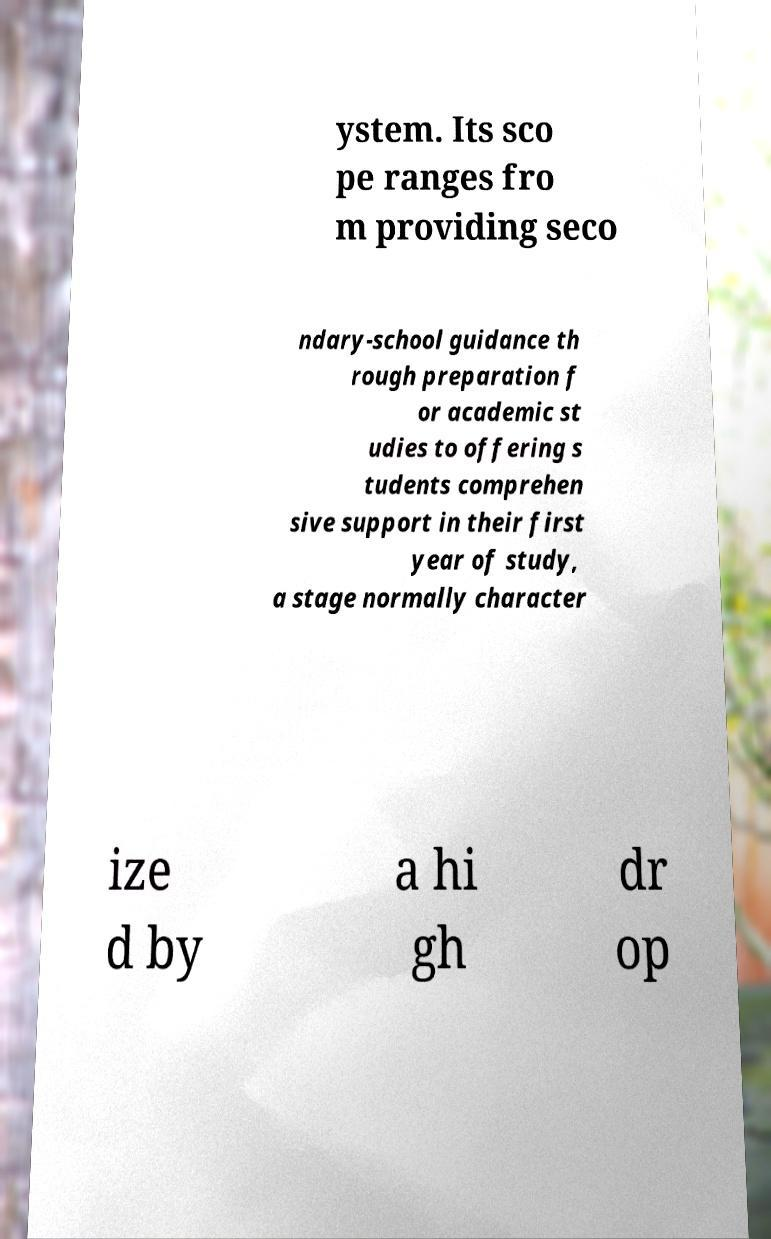Could you assist in decoding the text presented in this image and type it out clearly? ystem. Its sco pe ranges fro m providing seco ndary-school guidance th rough preparation f or academic st udies to offering s tudents comprehen sive support in their first year of study, a stage normally character ize d by a hi gh dr op 